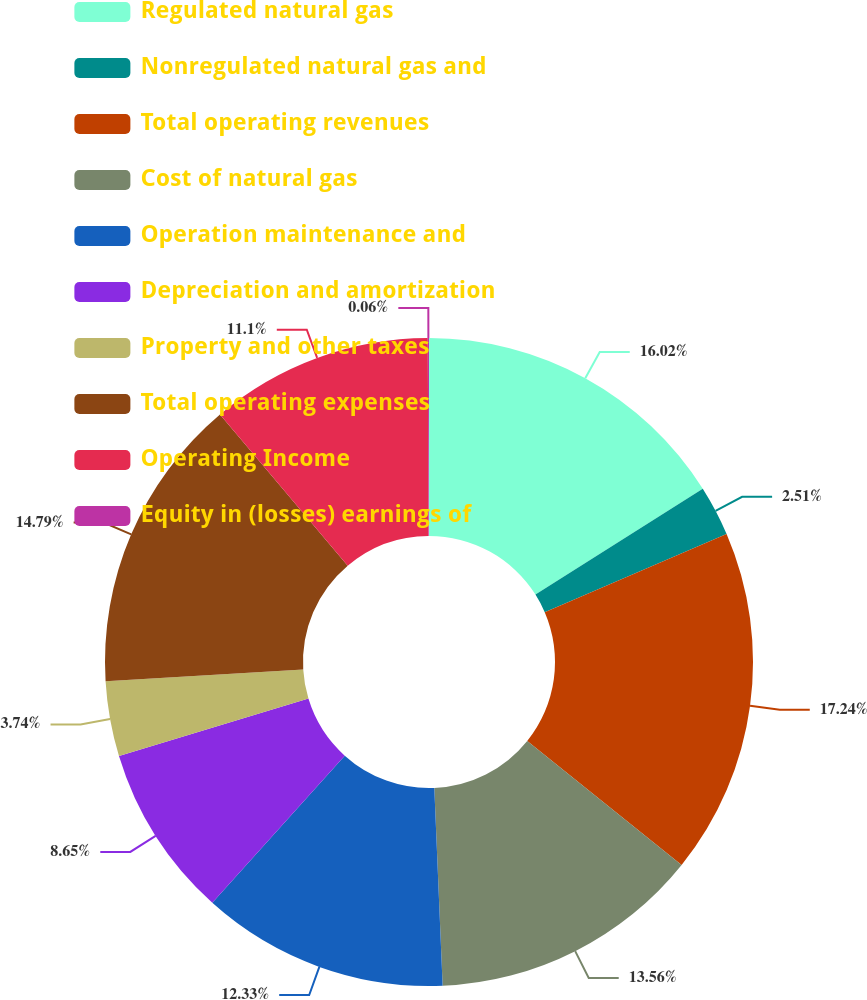Convert chart. <chart><loc_0><loc_0><loc_500><loc_500><pie_chart><fcel>Regulated natural gas<fcel>Nonregulated natural gas and<fcel>Total operating revenues<fcel>Cost of natural gas<fcel>Operation maintenance and<fcel>Depreciation and amortization<fcel>Property and other taxes<fcel>Total operating expenses<fcel>Operating Income<fcel>Equity in (losses) earnings of<nl><fcel>16.02%<fcel>2.51%<fcel>17.24%<fcel>13.56%<fcel>12.33%<fcel>8.65%<fcel>3.74%<fcel>14.79%<fcel>11.1%<fcel>0.06%<nl></chart> 